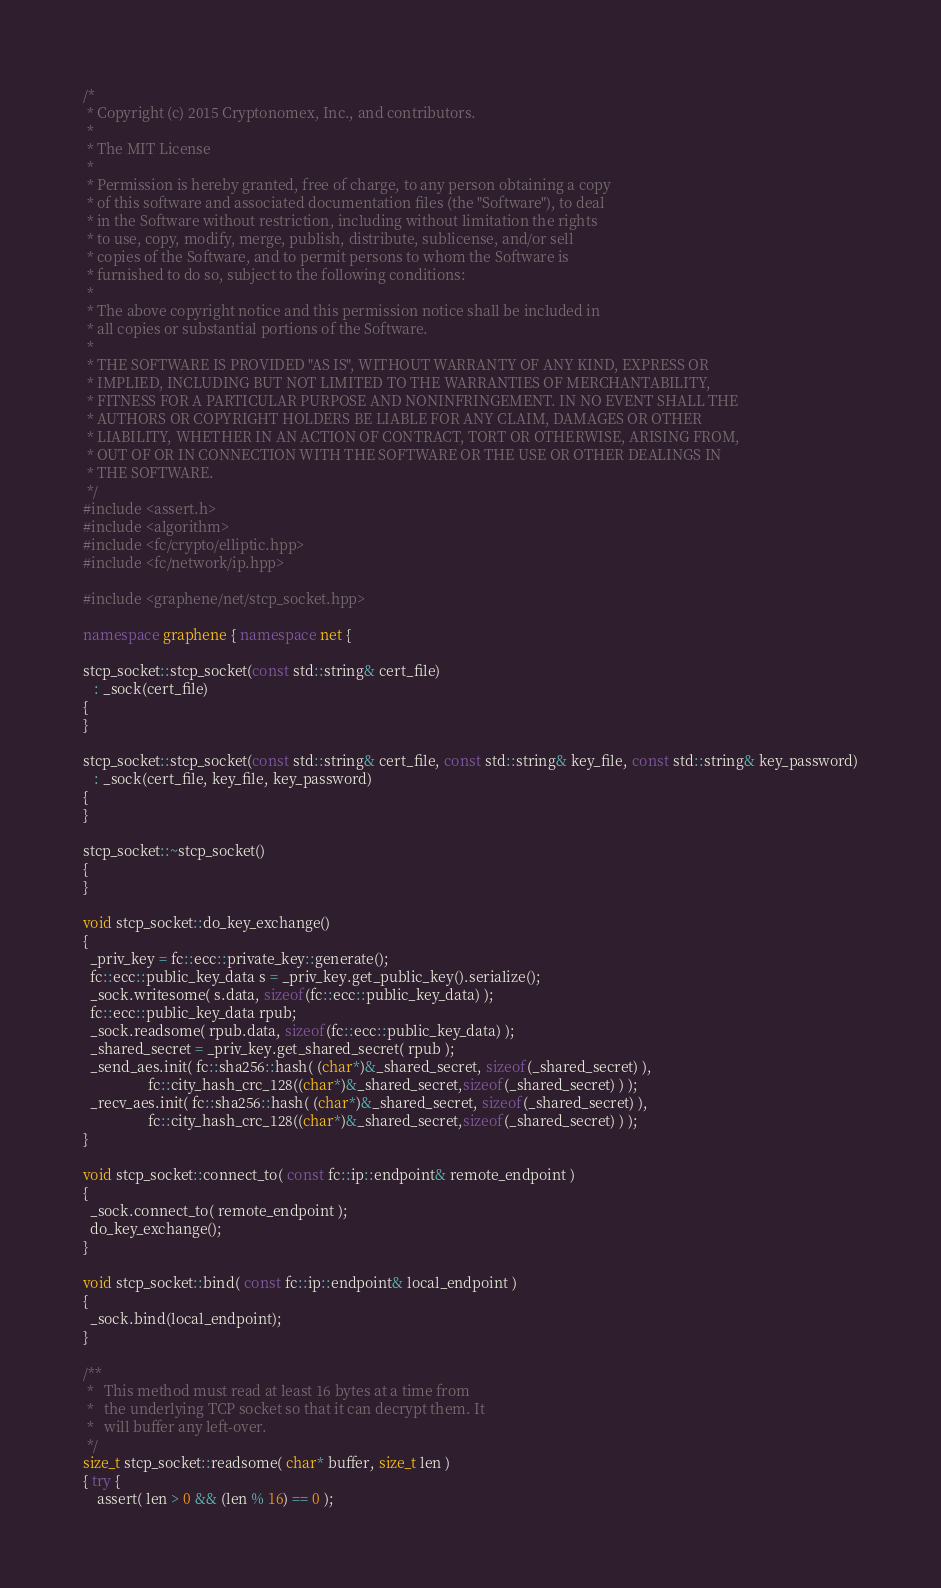<code> <loc_0><loc_0><loc_500><loc_500><_C++_>/*
 * Copyright (c) 2015 Cryptonomex, Inc., and contributors.
 *
 * The MIT License
 *
 * Permission is hereby granted, free of charge, to any person obtaining a copy
 * of this software and associated documentation files (the "Software"), to deal
 * in the Software without restriction, including without limitation the rights
 * to use, copy, modify, merge, publish, distribute, sublicense, and/or sell
 * copies of the Software, and to permit persons to whom the Software is
 * furnished to do so, subject to the following conditions:
 *
 * The above copyright notice and this permission notice shall be included in
 * all copies or substantial portions of the Software.
 *
 * THE SOFTWARE IS PROVIDED "AS IS", WITHOUT WARRANTY OF ANY KIND, EXPRESS OR
 * IMPLIED, INCLUDING BUT NOT LIMITED TO THE WARRANTIES OF MERCHANTABILITY,
 * FITNESS FOR A PARTICULAR PURPOSE AND NONINFRINGEMENT. IN NO EVENT SHALL THE
 * AUTHORS OR COPYRIGHT HOLDERS BE LIABLE FOR ANY CLAIM, DAMAGES OR OTHER
 * LIABILITY, WHETHER IN AN ACTION OF CONTRACT, TORT OR OTHERWISE, ARISING FROM,
 * OUT OF OR IN CONNECTION WITH THE SOFTWARE OR THE USE OR OTHER DEALINGS IN
 * THE SOFTWARE.
 */
#include <assert.h>
#include <algorithm>
#include <fc/crypto/elliptic.hpp>
#include <fc/network/ip.hpp>

#include <graphene/net/stcp_socket.hpp>

namespace graphene { namespace net {

stcp_socket::stcp_socket(const std::string& cert_file)
   : _sock(cert_file)
{
}

stcp_socket::stcp_socket(const std::string& cert_file, const std::string& key_file, const std::string& key_password)
   : _sock(cert_file, key_file, key_password)
{
}

stcp_socket::~stcp_socket()
{
}

void stcp_socket::do_key_exchange()
{
  _priv_key = fc::ecc::private_key::generate();
  fc::ecc::public_key_data s = _priv_key.get_public_key().serialize();
  _sock.writesome( s.data, sizeof(fc::ecc::public_key_data) );
  fc::ecc::public_key_data rpub;
  _sock.readsome( rpub.data, sizeof(fc::ecc::public_key_data) );
  _shared_secret = _priv_key.get_shared_secret( rpub );
  _send_aes.init( fc::sha256::hash( (char*)&_shared_secret, sizeof(_shared_secret) ),
                  fc::city_hash_crc_128((char*)&_shared_secret,sizeof(_shared_secret) ) );
  _recv_aes.init( fc::sha256::hash( (char*)&_shared_secret, sizeof(_shared_secret) ),
                  fc::city_hash_crc_128((char*)&_shared_secret,sizeof(_shared_secret) ) );
}

void stcp_socket::connect_to( const fc::ip::endpoint& remote_endpoint )
{
  _sock.connect_to( remote_endpoint );
  do_key_exchange();
}

void stcp_socket::bind( const fc::ip::endpoint& local_endpoint )
{
  _sock.bind(local_endpoint);
}

/**
 *   This method must read at least 16 bytes at a time from
 *   the underlying TCP socket so that it can decrypt them. It
 *   will buffer any left-over.
 */
size_t stcp_socket::readsome( char* buffer, size_t len )
{ try {
    assert( len > 0 && (len % 16) == 0 );
</code> 